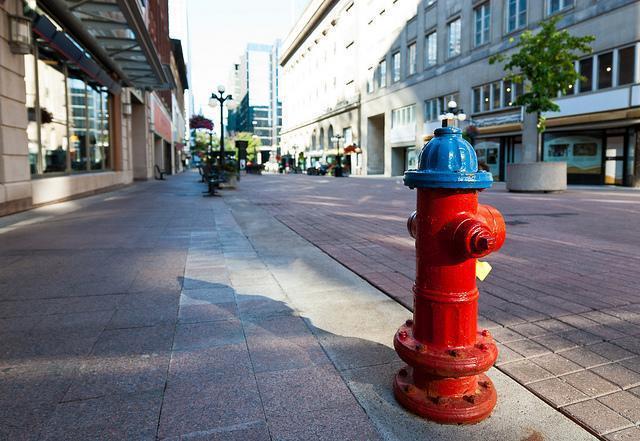How many potted plants are visible?
Give a very brief answer. 1. How many zebras are here?
Give a very brief answer. 0. 